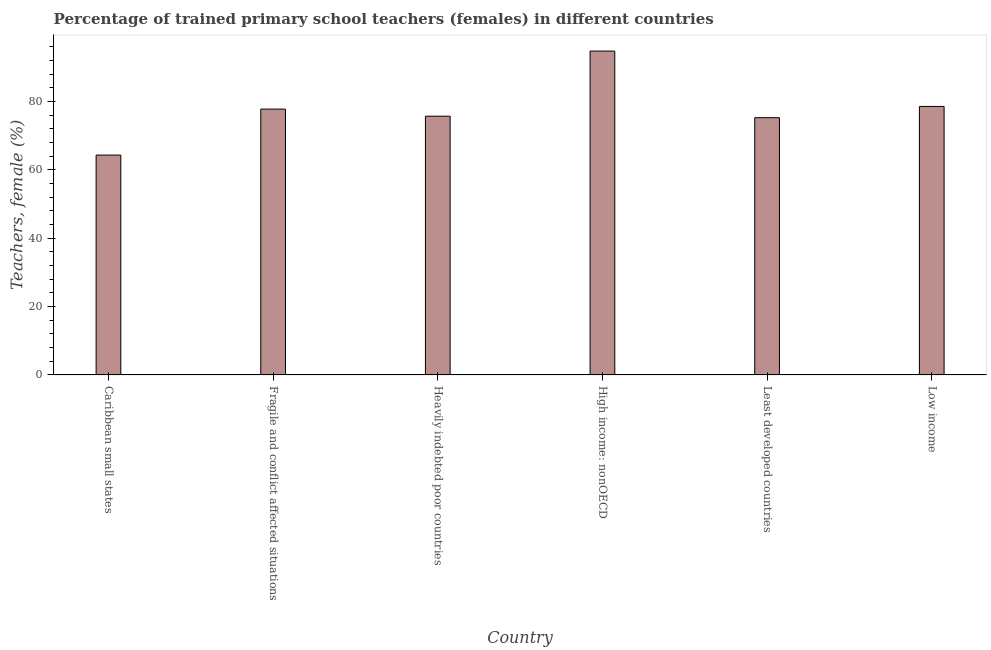Does the graph contain any zero values?
Keep it short and to the point. No. Does the graph contain grids?
Provide a short and direct response. No. What is the title of the graph?
Keep it short and to the point. Percentage of trained primary school teachers (females) in different countries. What is the label or title of the Y-axis?
Make the answer very short. Teachers, female (%). What is the percentage of trained female teachers in Fragile and conflict affected situations?
Make the answer very short. 77.81. Across all countries, what is the maximum percentage of trained female teachers?
Your response must be concise. 94.79. Across all countries, what is the minimum percentage of trained female teachers?
Give a very brief answer. 64.35. In which country was the percentage of trained female teachers maximum?
Provide a short and direct response. High income: nonOECD. In which country was the percentage of trained female teachers minimum?
Offer a very short reply. Caribbean small states. What is the sum of the percentage of trained female teachers?
Provide a short and direct response. 466.55. What is the difference between the percentage of trained female teachers in Heavily indebted poor countries and High income: nonOECD?
Ensure brevity in your answer.  -19.07. What is the average percentage of trained female teachers per country?
Your answer should be compact. 77.76. What is the median percentage of trained female teachers?
Provide a succinct answer. 76.77. What is the ratio of the percentage of trained female teachers in Least developed countries to that in Low income?
Give a very brief answer. 0.96. Is the percentage of trained female teachers in High income: nonOECD less than that in Least developed countries?
Your response must be concise. No. Is the difference between the percentage of trained female teachers in Caribbean small states and Heavily indebted poor countries greater than the difference between any two countries?
Offer a terse response. No. What is the difference between the highest and the second highest percentage of trained female teachers?
Your answer should be very brief. 16.21. What is the difference between the highest and the lowest percentage of trained female teachers?
Keep it short and to the point. 30.44. What is the difference between two consecutive major ticks on the Y-axis?
Give a very brief answer. 20. What is the Teachers, female (%) in Caribbean small states?
Provide a short and direct response. 64.35. What is the Teachers, female (%) of Fragile and conflict affected situations?
Make the answer very short. 77.81. What is the Teachers, female (%) of Heavily indebted poor countries?
Ensure brevity in your answer.  75.72. What is the Teachers, female (%) in High income: nonOECD?
Offer a very short reply. 94.79. What is the Teachers, female (%) in Least developed countries?
Your response must be concise. 75.29. What is the Teachers, female (%) of Low income?
Provide a succinct answer. 78.58. What is the difference between the Teachers, female (%) in Caribbean small states and Fragile and conflict affected situations?
Give a very brief answer. -13.45. What is the difference between the Teachers, female (%) in Caribbean small states and Heavily indebted poor countries?
Provide a succinct answer. -11.37. What is the difference between the Teachers, female (%) in Caribbean small states and High income: nonOECD?
Offer a terse response. -30.44. What is the difference between the Teachers, female (%) in Caribbean small states and Least developed countries?
Your response must be concise. -10.94. What is the difference between the Teachers, female (%) in Caribbean small states and Low income?
Provide a succinct answer. -14.23. What is the difference between the Teachers, female (%) in Fragile and conflict affected situations and Heavily indebted poor countries?
Your response must be concise. 2.08. What is the difference between the Teachers, female (%) in Fragile and conflict affected situations and High income: nonOECD?
Ensure brevity in your answer.  -16.99. What is the difference between the Teachers, female (%) in Fragile and conflict affected situations and Least developed countries?
Offer a terse response. 2.51. What is the difference between the Teachers, female (%) in Fragile and conflict affected situations and Low income?
Provide a succinct answer. -0.78. What is the difference between the Teachers, female (%) in Heavily indebted poor countries and High income: nonOECD?
Your answer should be compact. -19.07. What is the difference between the Teachers, female (%) in Heavily indebted poor countries and Least developed countries?
Provide a succinct answer. 0.43. What is the difference between the Teachers, female (%) in Heavily indebted poor countries and Low income?
Provide a succinct answer. -2.86. What is the difference between the Teachers, female (%) in High income: nonOECD and Least developed countries?
Offer a very short reply. 19.5. What is the difference between the Teachers, female (%) in High income: nonOECD and Low income?
Give a very brief answer. 16.21. What is the difference between the Teachers, female (%) in Least developed countries and Low income?
Offer a terse response. -3.29. What is the ratio of the Teachers, female (%) in Caribbean small states to that in Fragile and conflict affected situations?
Provide a succinct answer. 0.83. What is the ratio of the Teachers, female (%) in Caribbean small states to that in Heavily indebted poor countries?
Your response must be concise. 0.85. What is the ratio of the Teachers, female (%) in Caribbean small states to that in High income: nonOECD?
Keep it short and to the point. 0.68. What is the ratio of the Teachers, female (%) in Caribbean small states to that in Least developed countries?
Provide a short and direct response. 0.85. What is the ratio of the Teachers, female (%) in Caribbean small states to that in Low income?
Provide a short and direct response. 0.82. What is the ratio of the Teachers, female (%) in Fragile and conflict affected situations to that in Heavily indebted poor countries?
Offer a terse response. 1.03. What is the ratio of the Teachers, female (%) in Fragile and conflict affected situations to that in High income: nonOECD?
Offer a very short reply. 0.82. What is the ratio of the Teachers, female (%) in Fragile and conflict affected situations to that in Least developed countries?
Ensure brevity in your answer.  1.03. What is the ratio of the Teachers, female (%) in Heavily indebted poor countries to that in High income: nonOECD?
Offer a very short reply. 0.8. What is the ratio of the Teachers, female (%) in Heavily indebted poor countries to that in Least developed countries?
Your answer should be compact. 1.01. What is the ratio of the Teachers, female (%) in Heavily indebted poor countries to that in Low income?
Your answer should be very brief. 0.96. What is the ratio of the Teachers, female (%) in High income: nonOECD to that in Least developed countries?
Make the answer very short. 1.26. What is the ratio of the Teachers, female (%) in High income: nonOECD to that in Low income?
Offer a terse response. 1.21. What is the ratio of the Teachers, female (%) in Least developed countries to that in Low income?
Make the answer very short. 0.96. 